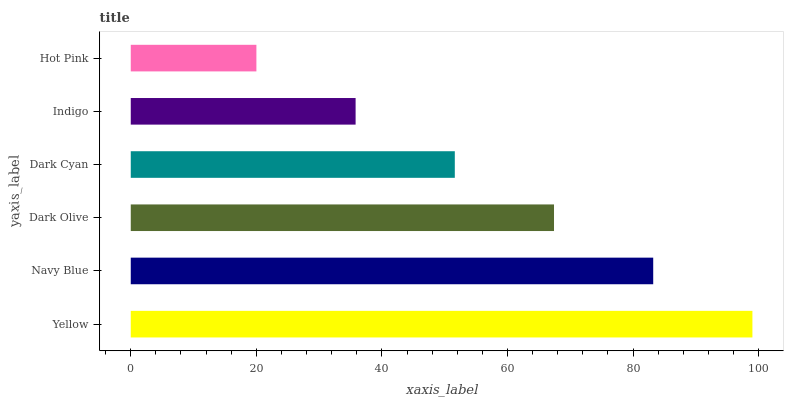Is Hot Pink the minimum?
Answer yes or no. Yes. Is Yellow the maximum?
Answer yes or no. Yes. Is Navy Blue the minimum?
Answer yes or no. No. Is Navy Blue the maximum?
Answer yes or no. No. Is Yellow greater than Navy Blue?
Answer yes or no. Yes. Is Navy Blue less than Yellow?
Answer yes or no. Yes. Is Navy Blue greater than Yellow?
Answer yes or no. No. Is Yellow less than Navy Blue?
Answer yes or no. No. Is Dark Olive the high median?
Answer yes or no. Yes. Is Dark Cyan the low median?
Answer yes or no. Yes. Is Navy Blue the high median?
Answer yes or no. No. Is Hot Pink the low median?
Answer yes or no. No. 